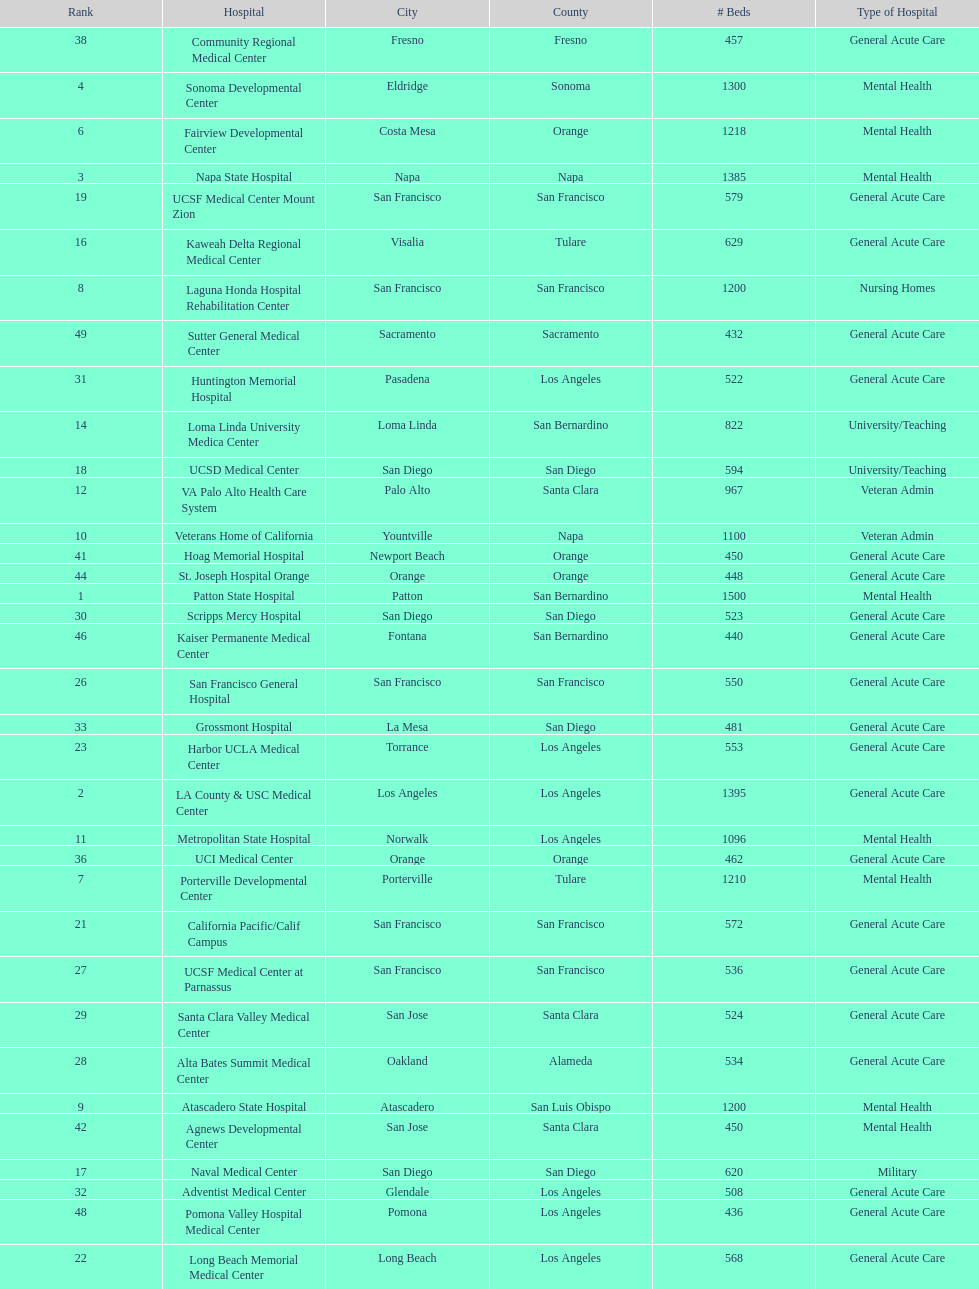Which type of hospitals are the same as grossmont hospital? General Acute Care. 